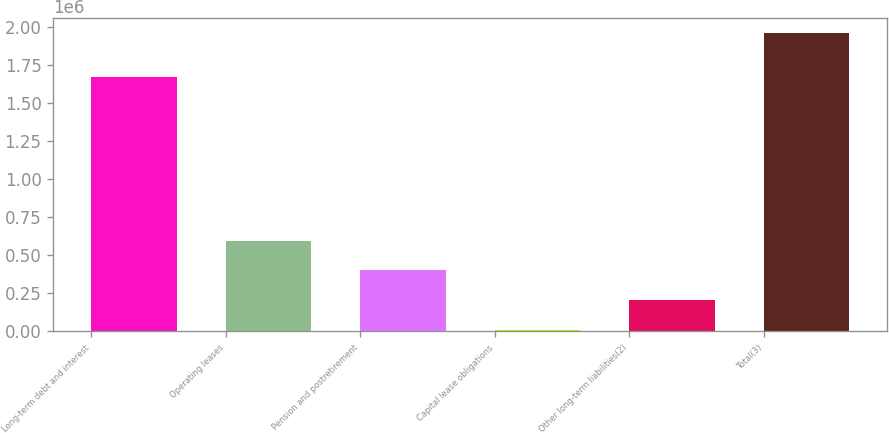Convert chart to OTSL. <chart><loc_0><loc_0><loc_500><loc_500><bar_chart><fcel>Long-term debt and interest<fcel>Operating leases<fcel>Pension and postretirement<fcel>Capital lease obligations<fcel>Other long-term liabilities(2)<fcel>Total(3)<nl><fcel>1.67193e+06<fcel>596835<fcel>401679<fcel>11366<fcel>206522<fcel>1.96293e+06<nl></chart> 